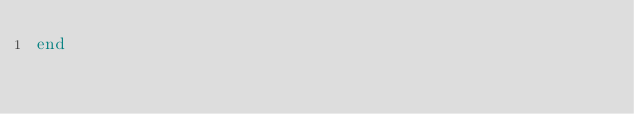<code> <loc_0><loc_0><loc_500><loc_500><_Ruby_>end
</code> 